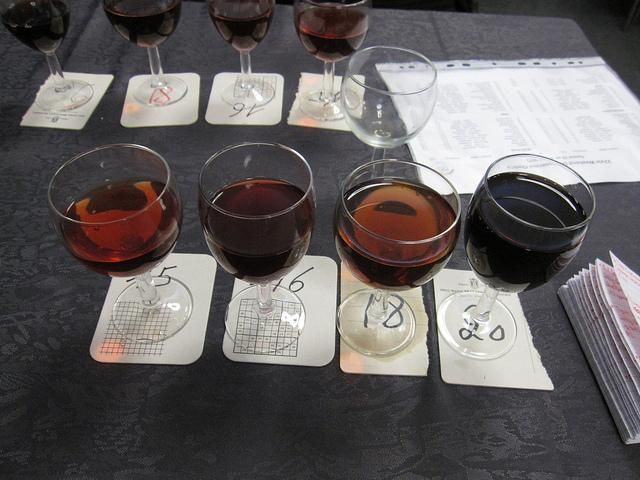What activity is the person taking this pic taking part in here?

Choices:
A) glutton fest
B) tasting
C) drunken toot
D) binge tasting 